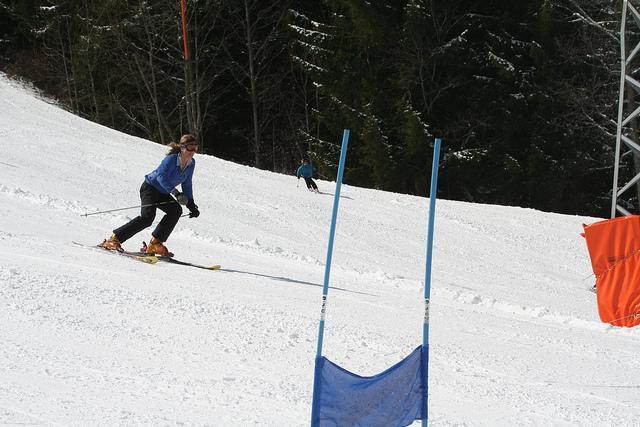How many nets are there?
Give a very brief answer. 2. 